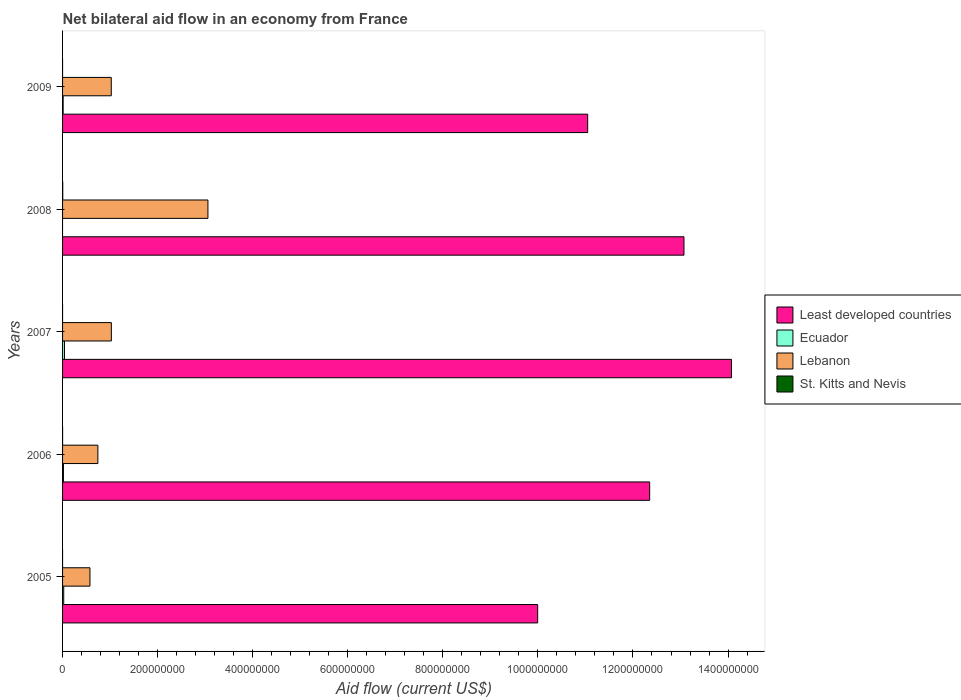How many groups of bars are there?
Keep it short and to the point. 5. Are the number of bars per tick equal to the number of legend labels?
Give a very brief answer. No. How many bars are there on the 4th tick from the top?
Your answer should be compact. 4. What is the net bilateral aid flow in Lebanon in 2008?
Make the answer very short. 3.06e+08. Across all years, what is the maximum net bilateral aid flow in Lebanon?
Your answer should be very brief. 3.06e+08. Across all years, what is the minimum net bilateral aid flow in Ecuador?
Keep it short and to the point. 0. What is the total net bilateral aid flow in Ecuador in the graph?
Offer a very short reply. 9.52e+06. What is the difference between the net bilateral aid flow in Lebanon in 2006 and that in 2008?
Offer a very short reply. -2.32e+08. What is the difference between the net bilateral aid flow in Least developed countries in 2006 and the net bilateral aid flow in St. Kitts and Nevis in 2007?
Your answer should be compact. 1.24e+09. What is the average net bilateral aid flow in Ecuador per year?
Your answer should be very brief. 1.90e+06. In the year 2009, what is the difference between the net bilateral aid flow in Lebanon and net bilateral aid flow in Ecuador?
Offer a very short reply. 1.01e+08. What is the ratio of the net bilateral aid flow in Lebanon in 2008 to that in 2009?
Offer a very short reply. 2.99. Is the net bilateral aid flow in Lebanon in 2006 less than that in 2008?
Provide a short and direct response. Yes. Is the difference between the net bilateral aid flow in Lebanon in 2005 and 2007 greater than the difference between the net bilateral aid flow in Ecuador in 2005 and 2007?
Offer a terse response. No. What is the difference between the highest and the second highest net bilateral aid flow in Ecuador?
Keep it short and to the point. 1.60e+06. In how many years, is the net bilateral aid flow in Least developed countries greater than the average net bilateral aid flow in Least developed countries taken over all years?
Give a very brief answer. 3. Is the sum of the net bilateral aid flow in Lebanon in 2008 and 2009 greater than the maximum net bilateral aid flow in Ecuador across all years?
Ensure brevity in your answer.  Yes. Are all the bars in the graph horizontal?
Ensure brevity in your answer.  Yes. How many years are there in the graph?
Offer a terse response. 5. Does the graph contain grids?
Keep it short and to the point. No. How are the legend labels stacked?
Your answer should be compact. Vertical. What is the title of the graph?
Keep it short and to the point. Net bilateral aid flow in an economy from France. Does "Iceland" appear as one of the legend labels in the graph?
Keep it short and to the point. No. What is the Aid flow (current US$) of Least developed countries in 2005?
Give a very brief answer. 1.00e+09. What is the Aid flow (current US$) of Ecuador in 2005?
Provide a succinct answer. 2.43e+06. What is the Aid flow (current US$) of Lebanon in 2005?
Keep it short and to the point. 5.76e+07. What is the Aid flow (current US$) of St. Kitts and Nevis in 2005?
Your answer should be compact. 0. What is the Aid flow (current US$) in Least developed countries in 2006?
Make the answer very short. 1.24e+09. What is the Aid flow (current US$) of Ecuador in 2006?
Your response must be concise. 1.82e+06. What is the Aid flow (current US$) of Lebanon in 2006?
Offer a terse response. 7.43e+07. What is the Aid flow (current US$) of St. Kitts and Nevis in 2006?
Provide a short and direct response. 10000. What is the Aid flow (current US$) of Least developed countries in 2007?
Ensure brevity in your answer.  1.41e+09. What is the Aid flow (current US$) of Ecuador in 2007?
Your response must be concise. 4.03e+06. What is the Aid flow (current US$) of Lebanon in 2007?
Provide a succinct answer. 1.03e+08. What is the Aid flow (current US$) in Least developed countries in 2008?
Keep it short and to the point. 1.31e+09. What is the Aid flow (current US$) of Ecuador in 2008?
Make the answer very short. 0. What is the Aid flow (current US$) of Lebanon in 2008?
Keep it short and to the point. 3.06e+08. What is the Aid flow (current US$) in Least developed countries in 2009?
Keep it short and to the point. 1.10e+09. What is the Aid flow (current US$) in Ecuador in 2009?
Ensure brevity in your answer.  1.24e+06. What is the Aid flow (current US$) in Lebanon in 2009?
Provide a succinct answer. 1.02e+08. Across all years, what is the maximum Aid flow (current US$) in Least developed countries?
Your answer should be very brief. 1.41e+09. Across all years, what is the maximum Aid flow (current US$) in Ecuador?
Your answer should be very brief. 4.03e+06. Across all years, what is the maximum Aid flow (current US$) in Lebanon?
Provide a short and direct response. 3.06e+08. Across all years, what is the maximum Aid flow (current US$) in St. Kitts and Nevis?
Your response must be concise. 3.60e+05. Across all years, what is the minimum Aid flow (current US$) in Least developed countries?
Keep it short and to the point. 1.00e+09. Across all years, what is the minimum Aid flow (current US$) in Ecuador?
Offer a very short reply. 0. Across all years, what is the minimum Aid flow (current US$) of Lebanon?
Offer a terse response. 5.76e+07. Across all years, what is the minimum Aid flow (current US$) in St. Kitts and Nevis?
Provide a succinct answer. 0. What is the total Aid flow (current US$) in Least developed countries in the graph?
Offer a very short reply. 6.05e+09. What is the total Aid flow (current US$) of Ecuador in the graph?
Ensure brevity in your answer.  9.52e+06. What is the total Aid flow (current US$) of Lebanon in the graph?
Ensure brevity in your answer.  6.43e+08. What is the difference between the Aid flow (current US$) in Least developed countries in 2005 and that in 2006?
Ensure brevity in your answer.  -2.36e+08. What is the difference between the Aid flow (current US$) of Lebanon in 2005 and that in 2006?
Offer a very short reply. -1.67e+07. What is the difference between the Aid flow (current US$) of Least developed countries in 2005 and that in 2007?
Offer a very short reply. -4.08e+08. What is the difference between the Aid flow (current US$) in Ecuador in 2005 and that in 2007?
Provide a short and direct response. -1.60e+06. What is the difference between the Aid flow (current US$) of Lebanon in 2005 and that in 2007?
Offer a very short reply. -4.50e+07. What is the difference between the Aid flow (current US$) in Least developed countries in 2005 and that in 2008?
Provide a succinct answer. -3.08e+08. What is the difference between the Aid flow (current US$) of Lebanon in 2005 and that in 2008?
Make the answer very short. -2.48e+08. What is the difference between the Aid flow (current US$) in Least developed countries in 2005 and that in 2009?
Your answer should be very brief. -1.05e+08. What is the difference between the Aid flow (current US$) in Ecuador in 2005 and that in 2009?
Your answer should be compact. 1.19e+06. What is the difference between the Aid flow (current US$) of Lebanon in 2005 and that in 2009?
Your response must be concise. -4.48e+07. What is the difference between the Aid flow (current US$) of Least developed countries in 2006 and that in 2007?
Your response must be concise. -1.72e+08. What is the difference between the Aid flow (current US$) of Ecuador in 2006 and that in 2007?
Keep it short and to the point. -2.21e+06. What is the difference between the Aid flow (current US$) of Lebanon in 2006 and that in 2007?
Your answer should be compact. -2.84e+07. What is the difference between the Aid flow (current US$) in Least developed countries in 2006 and that in 2008?
Provide a succinct answer. -7.21e+07. What is the difference between the Aid flow (current US$) of Lebanon in 2006 and that in 2008?
Provide a short and direct response. -2.32e+08. What is the difference between the Aid flow (current US$) of St. Kitts and Nevis in 2006 and that in 2008?
Provide a short and direct response. -3.50e+05. What is the difference between the Aid flow (current US$) in Least developed countries in 2006 and that in 2009?
Make the answer very short. 1.30e+08. What is the difference between the Aid flow (current US$) of Ecuador in 2006 and that in 2009?
Ensure brevity in your answer.  5.80e+05. What is the difference between the Aid flow (current US$) in Lebanon in 2006 and that in 2009?
Keep it short and to the point. -2.82e+07. What is the difference between the Aid flow (current US$) in Least developed countries in 2007 and that in 2008?
Keep it short and to the point. 9.99e+07. What is the difference between the Aid flow (current US$) in Lebanon in 2007 and that in 2008?
Provide a succinct answer. -2.03e+08. What is the difference between the Aid flow (current US$) of Least developed countries in 2007 and that in 2009?
Your answer should be compact. 3.03e+08. What is the difference between the Aid flow (current US$) in Ecuador in 2007 and that in 2009?
Provide a short and direct response. 2.79e+06. What is the difference between the Aid flow (current US$) of Lebanon in 2007 and that in 2009?
Ensure brevity in your answer.  1.80e+05. What is the difference between the Aid flow (current US$) in Least developed countries in 2008 and that in 2009?
Offer a very short reply. 2.03e+08. What is the difference between the Aid flow (current US$) in Lebanon in 2008 and that in 2009?
Give a very brief answer. 2.03e+08. What is the difference between the Aid flow (current US$) of Least developed countries in 2005 and the Aid flow (current US$) of Ecuador in 2006?
Your response must be concise. 9.98e+08. What is the difference between the Aid flow (current US$) of Least developed countries in 2005 and the Aid flow (current US$) of Lebanon in 2006?
Offer a very short reply. 9.25e+08. What is the difference between the Aid flow (current US$) of Least developed countries in 2005 and the Aid flow (current US$) of St. Kitts and Nevis in 2006?
Your answer should be compact. 9.99e+08. What is the difference between the Aid flow (current US$) in Ecuador in 2005 and the Aid flow (current US$) in Lebanon in 2006?
Your answer should be compact. -7.18e+07. What is the difference between the Aid flow (current US$) in Ecuador in 2005 and the Aid flow (current US$) in St. Kitts and Nevis in 2006?
Ensure brevity in your answer.  2.42e+06. What is the difference between the Aid flow (current US$) of Lebanon in 2005 and the Aid flow (current US$) of St. Kitts and Nevis in 2006?
Offer a very short reply. 5.76e+07. What is the difference between the Aid flow (current US$) of Least developed countries in 2005 and the Aid flow (current US$) of Ecuador in 2007?
Your response must be concise. 9.95e+08. What is the difference between the Aid flow (current US$) of Least developed countries in 2005 and the Aid flow (current US$) of Lebanon in 2007?
Ensure brevity in your answer.  8.97e+08. What is the difference between the Aid flow (current US$) in Ecuador in 2005 and the Aid flow (current US$) in Lebanon in 2007?
Provide a succinct answer. -1.00e+08. What is the difference between the Aid flow (current US$) of Least developed countries in 2005 and the Aid flow (current US$) of Lebanon in 2008?
Ensure brevity in your answer.  6.94e+08. What is the difference between the Aid flow (current US$) of Least developed countries in 2005 and the Aid flow (current US$) of St. Kitts and Nevis in 2008?
Offer a terse response. 9.99e+08. What is the difference between the Aid flow (current US$) of Ecuador in 2005 and the Aid flow (current US$) of Lebanon in 2008?
Your answer should be compact. -3.03e+08. What is the difference between the Aid flow (current US$) in Ecuador in 2005 and the Aid flow (current US$) in St. Kitts and Nevis in 2008?
Your answer should be very brief. 2.07e+06. What is the difference between the Aid flow (current US$) of Lebanon in 2005 and the Aid flow (current US$) of St. Kitts and Nevis in 2008?
Your answer should be compact. 5.72e+07. What is the difference between the Aid flow (current US$) of Least developed countries in 2005 and the Aid flow (current US$) of Ecuador in 2009?
Give a very brief answer. 9.98e+08. What is the difference between the Aid flow (current US$) in Least developed countries in 2005 and the Aid flow (current US$) in Lebanon in 2009?
Ensure brevity in your answer.  8.97e+08. What is the difference between the Aid flow (current US$) of Ecuador in 2005 and the Aid flow (current US$) of Lebanon in 2009?
Your response must be concise. -1.00e+08. What is the difference between the Aid flow (current US$) in Least developed countries in 2006 and the Aid flow (current US$) in Ecuador in 2007?
Offer a terse response. 1.23e+09. What is the difference between the Aid flow (current US$) of Least developed countries in 2006 and the Aid flow (current US$) of Lebanon in 2007?
Provide a succinct answer. 1.13e+09. What is the difference between the Aid flow (current US$) of Ecuador in 2006 and the Aid flow (current US$) of Lebanon in 2007?
Your response must be concise. -1.01e+08. What is the difference between the Aid flow (current US$) of Least developed countries in 2006 and the Aid flow (current US$) of Lebanon in 2008?
Your answer should be very brief. 9.29e+08. What is the difference between the Aid flow (current US$) of Least developed countries in 2006 and the Aid flow (current US$) of St. Kitts and Nevis in 2008?
Keep it short and to the point. 1.23e+09. What is the difference between the Aid flow (current US$) in Ecuador in 2006 and the Aid flow (current US$) in Lebanon in 2008?
Your answer should be compact. -3.04e+08. What is the difference between the Aid flow (current US$) of Ecuador in 2006 and the Aid flow (current US$) of St. Kitts and Nevis in 2008?
Your response must be concise. 1.46e+06. What is the difference between the Aid flow (current US$) of Lebanon in 2006 and the Aid flow (current US$) of St. Kitts and Nevis in 2008?
Ensure brevity in your answer.  7.39e+07. What is the difference between the Aid flow (current US$) of Least developed countries in 2006 and the Aid flow (current US$) of Ecuador in 2009?
Provide a short and direct response. 1.23e+09. What is the difference between the Aid flow (current US$) of Least developed countries in 2006 and the Aid flow (current US$) of Lebanon in 2009?
Offer a terse response. 1.13e+09. What is the difference between the Aid flow (current US$) in Ecuador in 2006 and the Aid flow (current US$) in Lebanon in 2009?
Offer a terse response. -1.01e+08. What is the difference between the Aid flow (current US$) of Least developed countries in 2007 and the Aid flow (current US$) of Lebanon in 2008?
Ensure brevity in your answer.  1.10e+09. What is the difference between the Aid flow (current US$) in Least developed countries in 2007 and the Aid flow (current US$) in St. Kitts and Nevis in 2008?
Ensure brevity in your answer.  1.41e+09. What is the difference between the Aid flow (current US$) of Ecuador in 2007 and the Aid flow (current US$) of Lebanon in 2008?
Your answer should be compact. -3.02e+08. What is the difference between the Aid flow (current US$) in Ecuador in 2007 and the Aid flow (current US$) in St. Kitts and Nevis in 2008?
Ensure brevity in your answer.  3.67e+06. What is the difference between the Aid flow (current US$) in Lebanon in 2007 and the Aid flow (current US$) in St. Kitts and Nevis in 2008?
Keep it short and to the point. 1.02e+08. What is the difference between the Aid flow (current US$) in Least developed countries in 2007 and the Aid flow (current US$) in Ecuador in 2009?
Your answer should be very brief. 1.41e+09. What is the difference between the Aid flow (current US$) of Least developed countries in 2007 and the Aid flow (current US$) of Lebanon in 2009?
Your answer should be compact. 1.30e+09. What is the difference between the Aid flow (current US$) in Ecuador in 2007 and the Aid flow (current US$) in Lebanon in 2009?
Offer a very short reply. -9.84e+07. What is the difference between the Aid flow (current US$) of Least developed countries in 2008 and the Aid flow (current US$) of Ecuador in 2009?
Provide a succinct answer. 1.31e+09. What is the difference between the Aid flow (current US$) of Least developed countries in 2008 and the Aid flow (current US$) of Lebanon in 2009?
Your answer should be very brief. 1.20e+09. What is the average Aid flow (current US$) in Least developed countries per year?
Offer a very short reply. 1.21e+09. What is the average Aid flow (current US$) of Ecuador per year?
Offer a terse response. 1.90e+06. What is the average Aid flow (current US$) of Lebanon per year?
Provide a short and direct response. 1.29e+08. What is the average Aid flow (current US$) of St. Kitts and Nevis per year?
Provide a succinct answer. 7.40e+04. In the year 2005, what is the difference between the Aid flow (current US$) in Least developed countries and Aid flow (current US$) in Ecuador?
Provide a short and direct response. 9.97e+08. In the year 2005, what is the difference between the Aid flow (current US$) in Least developed countries and Aid flow (current US$) in Lebanon?
Provide a succinct answer. 9.42e+08. In the year 2005, what is the difference between the Aid flow (current US$) of Ecuador and Aid flow (current US$) of Lebanon?
Keep it short and to the point. -5.52e+07. In the year 2006, what is the difference between the Aid flow (current US$) in Least developed countries and Aid flow (current US$) in Ecuador?
Offer a very short reply. 1.23e+09. In the year 2006, what is the difference between the Aid flow (current US$) in Least developed countries and Aid flow (current US$) in Lebanon?
Ensure brevity in your answer.  1.16e+09. In the year 2006, what is the difference between the Aid flow (current US$) in Least developed countries and Aid flow (current US$) in St. Kitts and Nevis?
Offer a terse response. 1.24e+09. In the year 2006, what is the difference between the Aid flow (current US$) of Ecuador and Aid flow (current US$) of Lebanon?
Provide a succinct answer. -7.24e+07. In the year 2006, what is the difference between the Aid flow (current US$) in Ecuador and Aid flow (current US$) in St. Kitts and Nevis?
Your response must be concise. 1.81e+06. In the year 2006, what is the difference between the Aid flow (current US$) of Lebanon and Aid flow (current US$) of St. Kitts and Nevis?
Your answer should be compact. 7.43e+07. In the year 2007, what is the difference between the Aid flow (current US$) in Least developed countries and Aid flow (current US$) in Ecuador?
Give a very brief answer. 1.40e+09. In the year 2007, what is the difference between the Aid flow (current US$) of Least developed countries and Aid flow (current US$) of Lebanon?
Ensure brevity in your answer.  1.30e+09. In the year 2007, what is the difference between the Aid flow (current US$) in Ecuador and Aid flow (current US$) in Lebanon?
Your response must be concise. -9.86e+07. In the year 2008, what is the difference between the Aid flow (current US$) of Least developed countries and Aid flow (current US$) of Lebanon?
Provide a short and direct response. 1.00e+09. In the year 2008, what is the difference between the Aid flow (current US$) of Least developed countries and Aid flow (current US$) of St. Kitts and Nevis?
Provide a succinct answer. 1.31e+09. In the year 2008, what is the difference between the Aid flow (current US$) in Lebanon and Aid flow (current US$) in St. Kitts and Nevis?
Offer a terse response. 3.05e+08. In the year 2009, what is the difference between the Aid flow (current US$) in Least developed countries and Aid flow (current US$) in Ecuador?
Make the answer very short. 1.10e+09. In the year 2009, what is the difference between the Aid flow (current US$) in Least developed countries and Aid flow (current US$) in Lebanon?
Provide a succinct answer. 1.00e+09. In the year 2009, what is the difference between the Aid flow (current US$) in Ecuador and Aid flow (current US$) in Lebanon?
Provide a short and direct response. -1.01e+08. What is the ratio of the Aid flow (current US$) in Least developed countries in 2005 to that in 2006?
Your response must be concise. 0.81. What is the ratio of the Aid flow (current US$) in Ecuador in 2005 to that in 2006?
Provide a succinct answer. 1.34. What is the ratio of the Aid flow (current US$) of Lebanon in 2005 to that in 2006?
Your answer should be compact. 0.78. What is the ratio of the Aid flow (current US$) in Least developed countries in 2005 to that in 2007?
Your answer should be compact. 0.71. What is the ratio of the Aid flow (current US$) in Ecuador in 2005 to that in 2007?
Provide a short and direct response. 0.6. What is the ratio of the Aid flow (current US$) in Lebanon in 2005 to that in 2007?
Give a very brief answer. 0.56. What is the ratio of the Aid flow (current US$) in Least developed countries in 2005 to that in 2008?
Offer a terse response. 0.76. What is the ratio of the Aid flow (current US$) of Lebanon in 2005 to that in 2008?
Provide a succinct answer. 0.19. What is the ratio of the Aid flow (current US$) of Least developed countries in 2005 to that in 2009?
Keep it short and to the point. 0.9. What is the ratio of the Aid flow (current US$) of Ecuador in 2005 to that in 2009?
Offer a terse response. 1.96. What is the ratio of the Aid flow (current US$) in Lebanon in 2005 to that in 2009?
Your response must be concise. 0.56. What is the ratio of the Aid flow (current US$) of Least developed countries in 2006 to that in 2007?
Your response must be concise. 0.88. What is the ratio of the Aid flow (current US$) in Ecuador in 2006 to that in 2007?
Provide a short and direct response. 0.45. What is the ratio of the Aid flow (current US$) of Lebanon in 2006 to that in 2007?
Offer a terse response. 0.72. What is the ratio of the Aid flow (current US$) in Least developed countries in 2006 to that in 2008?
Make the answer very short. 0.94. What is the ratio of the Aid flow (current US$) of Lebanon in 2006 to that in 2008?
Keep it short and to the point. 0.24. What is the ratio of the Aid flow (current US$) in St. Kitts and Nevis in 2006 to that in 2008?
Offer a terse response. 0.03. What is the ratio of the Aid flow (current US$) of Least developed countries in 2006 to that in 2009?
Make the answer very short. 1.12. What is the ratio of the Aid flow (current US$) in Ecuador in 2006 to that in 2009?
Offer a terse response. 1.47. What is the ratio of the Aid flow (current US$) in Lebanon in 2006 to that in 2009?
Keep it short and to the point. 0.72. What is the ratio of the Aid flow (current US$) of Least developed countries in 2007 to that in 2008?
Make the answer very short. 1.08. What is the ratio of the Aid flow (current US$) in Lebanon in 2007 to that in 2008?
Offer a terse response. 0.34. What is the ratio of the Aid flow (current US$) of Least developed countries in 2007 to that in 2009?
Offer a terse response. 1.27. What is the ratio of the Aid flow (current US$) in Ecuador in 2007 to that in 2009?
Offer a terse response. 3.25. What is the ratio of the Aid flow (current US$) in Least developed countries in 2008 to that in 2009?
Keep it short and to the point. 1.18. What is the ratio of the Aid flow (current US$) of Lebanon in 2008 to that in 2009?
Offer a terse response. 2.99. What is the difference between the highest and the second highest Aid flow (current US$) of Least developed countries?
Ensure brevity in your answer.  9.99e+07. What is the difference between the highest and the second highest Aid flow (current US$) in Ecuador?
Your response must be concise. 1.60e+06. What is the difference between the highest and the second highest Aid flow (current US$) of Lebanon?
Your answer should be very brief. 2.03e+08. What is the difference between the highest and the lowest Aid flow (current US$) in Least developed countries?
Make the answer very short. 4.08e+08. What is the difference between the highest and the lowest Aid flow (current US$) of Ecuador?
Your answer should be compact. 4.03e+06. What is the difference between the highest and the lowest Aid flow (current US$) of Lebanon?
Provide a short and direct response. 2.48e+08. 